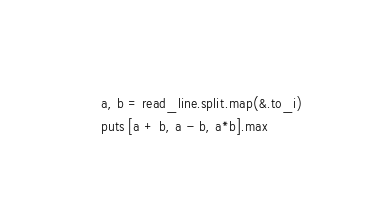<code> <loc_0><loc_0><loc_500><loc_500><_Crystal_>a, b = read_line.split.map(&.to_i)
puts [a + b, a - b, a*b].max
</code> 